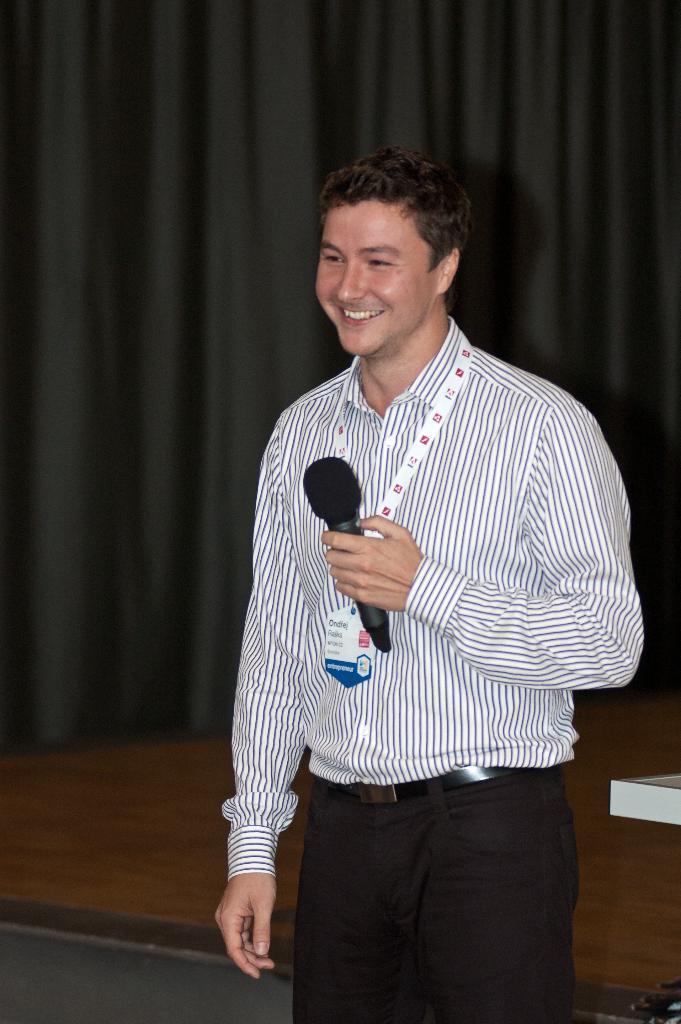Can you describe this image briefly? In this picture we can see a man holding a microphone. Behind the man, there is a curtain and it looks like a stage. 